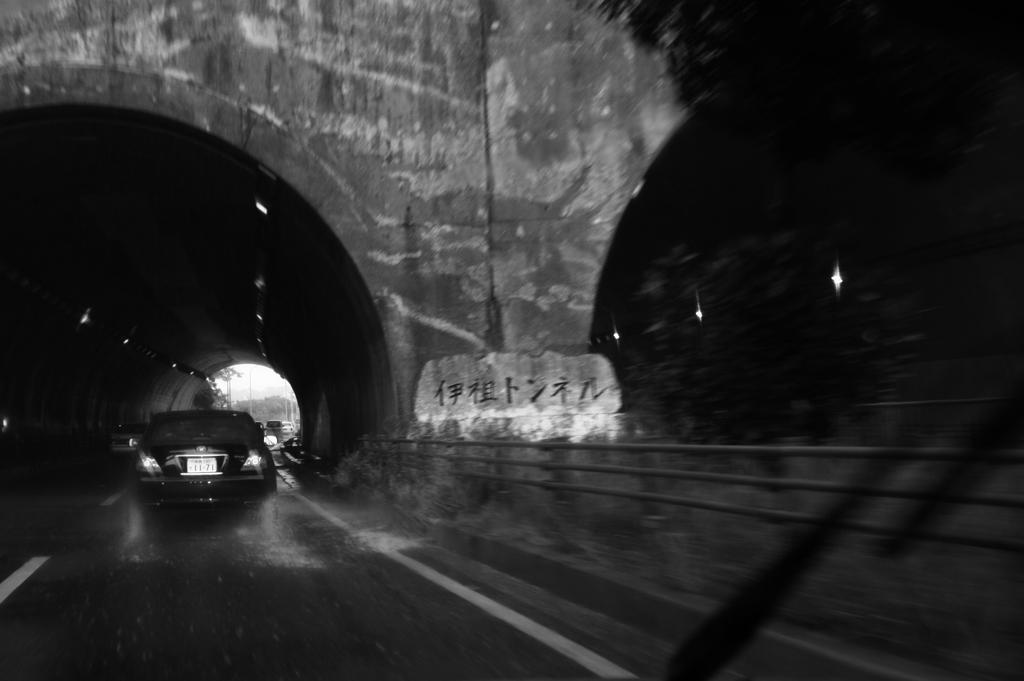What is the main feature of the image? The main feature of the image is a road under a tunnel. What can be seen on the road? There are vehicles on the road. What other tunnel is visible in the image? There is another tunnel with lights in the image. What is located near the second tunnel? There is a tree near the second tunnel. Where is the camera placed in the image? There is no camera visible in the image. What type of rail is present near the second tunnel? There is no rail present near the second tunnel in the image. 